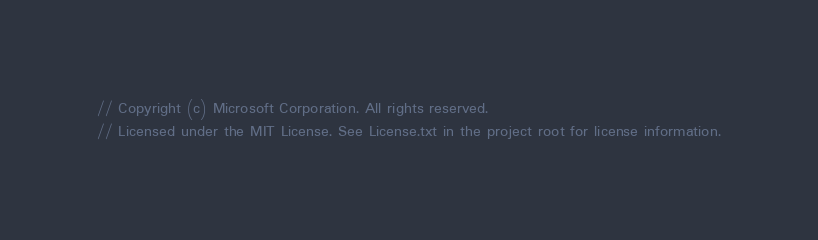<code> <loc_0><loc_0><loc_500><loc_500><_C#_>// Copyright (c) Microsoft Corporation. All rights reserved.
// Licensed under the MIT License. See License.txt in the project root for license information.</code> 